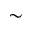<formula> <loc_0><loc_0><loc_500><loc_500>\sim</formula> 